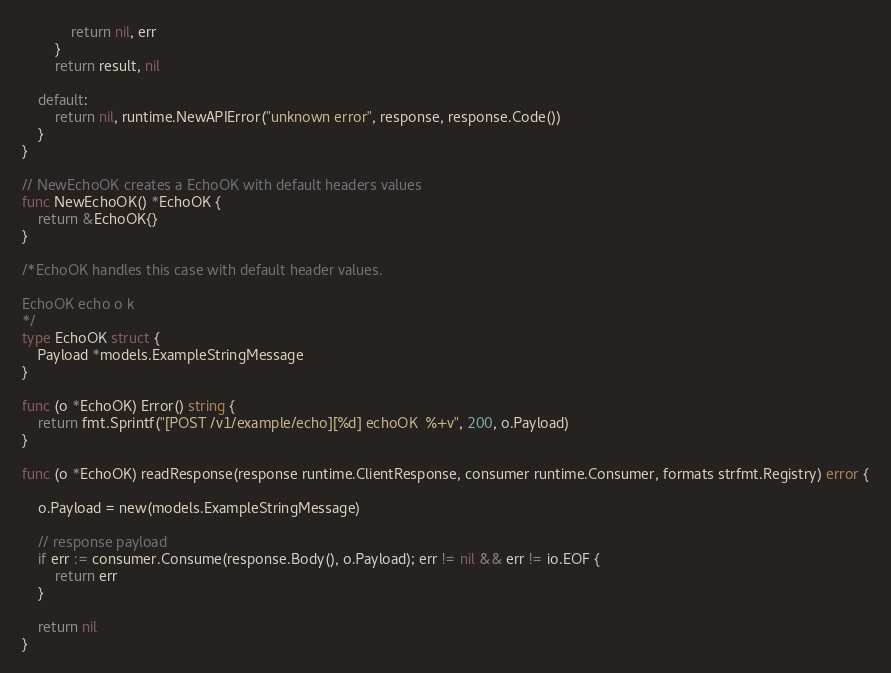<code> <loc_0><loc_0><loc_500><loc_500><_Go_>			return nil, err
		}
		return result, nil

	default:
		return nil, runtime.NewAPIError("unknown error", response, response.Code())
	}
}

// NewEchoOK creates a EchoOK with default headers values
func NewEchoOK() *EchoOK {
	return &EchoOK{}
}

/*EchoOK handles this case with default header values.

EchoOK echo o k
*/
type EchoOK struct {
	Payload *models.ExampleStringMessage
}

func (o *EchoOK) Error() string {
	return fmt.Sprintf("[POST /v1/example/echo][%d] echoOK  %+v", 200, o.Payload)
}

func (o *EchoOK) readResponse(response runtime.ClientResponse, consumer runtime.Consumer, formats strfmt.Registry) error {

	o.Payload = new(models.ExampleStringMessage)

	// response payload
	if err := consumer.Consume(response.Body(), o.Payload); err != nil && err != io.EOF {
		return err
	}

	return nil
}
</code> 